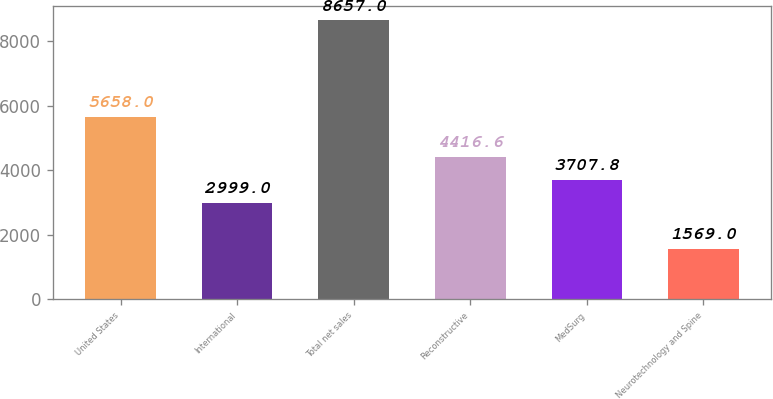Convert chart to OTSL. <chart><loc_0><loc_0><loc_500><loc_500><bar_chart><fcel>United States<fcel>International<fcel>Total net sales<fcel>Reconstructive<fcel>MedSurg<fcel>Neurotechnology and Spine<nl><fcel>5658<fcel>2999<fcel>8657<fcel>4416.6<fcel>3707.8<fcel>1569<nl></chart> 